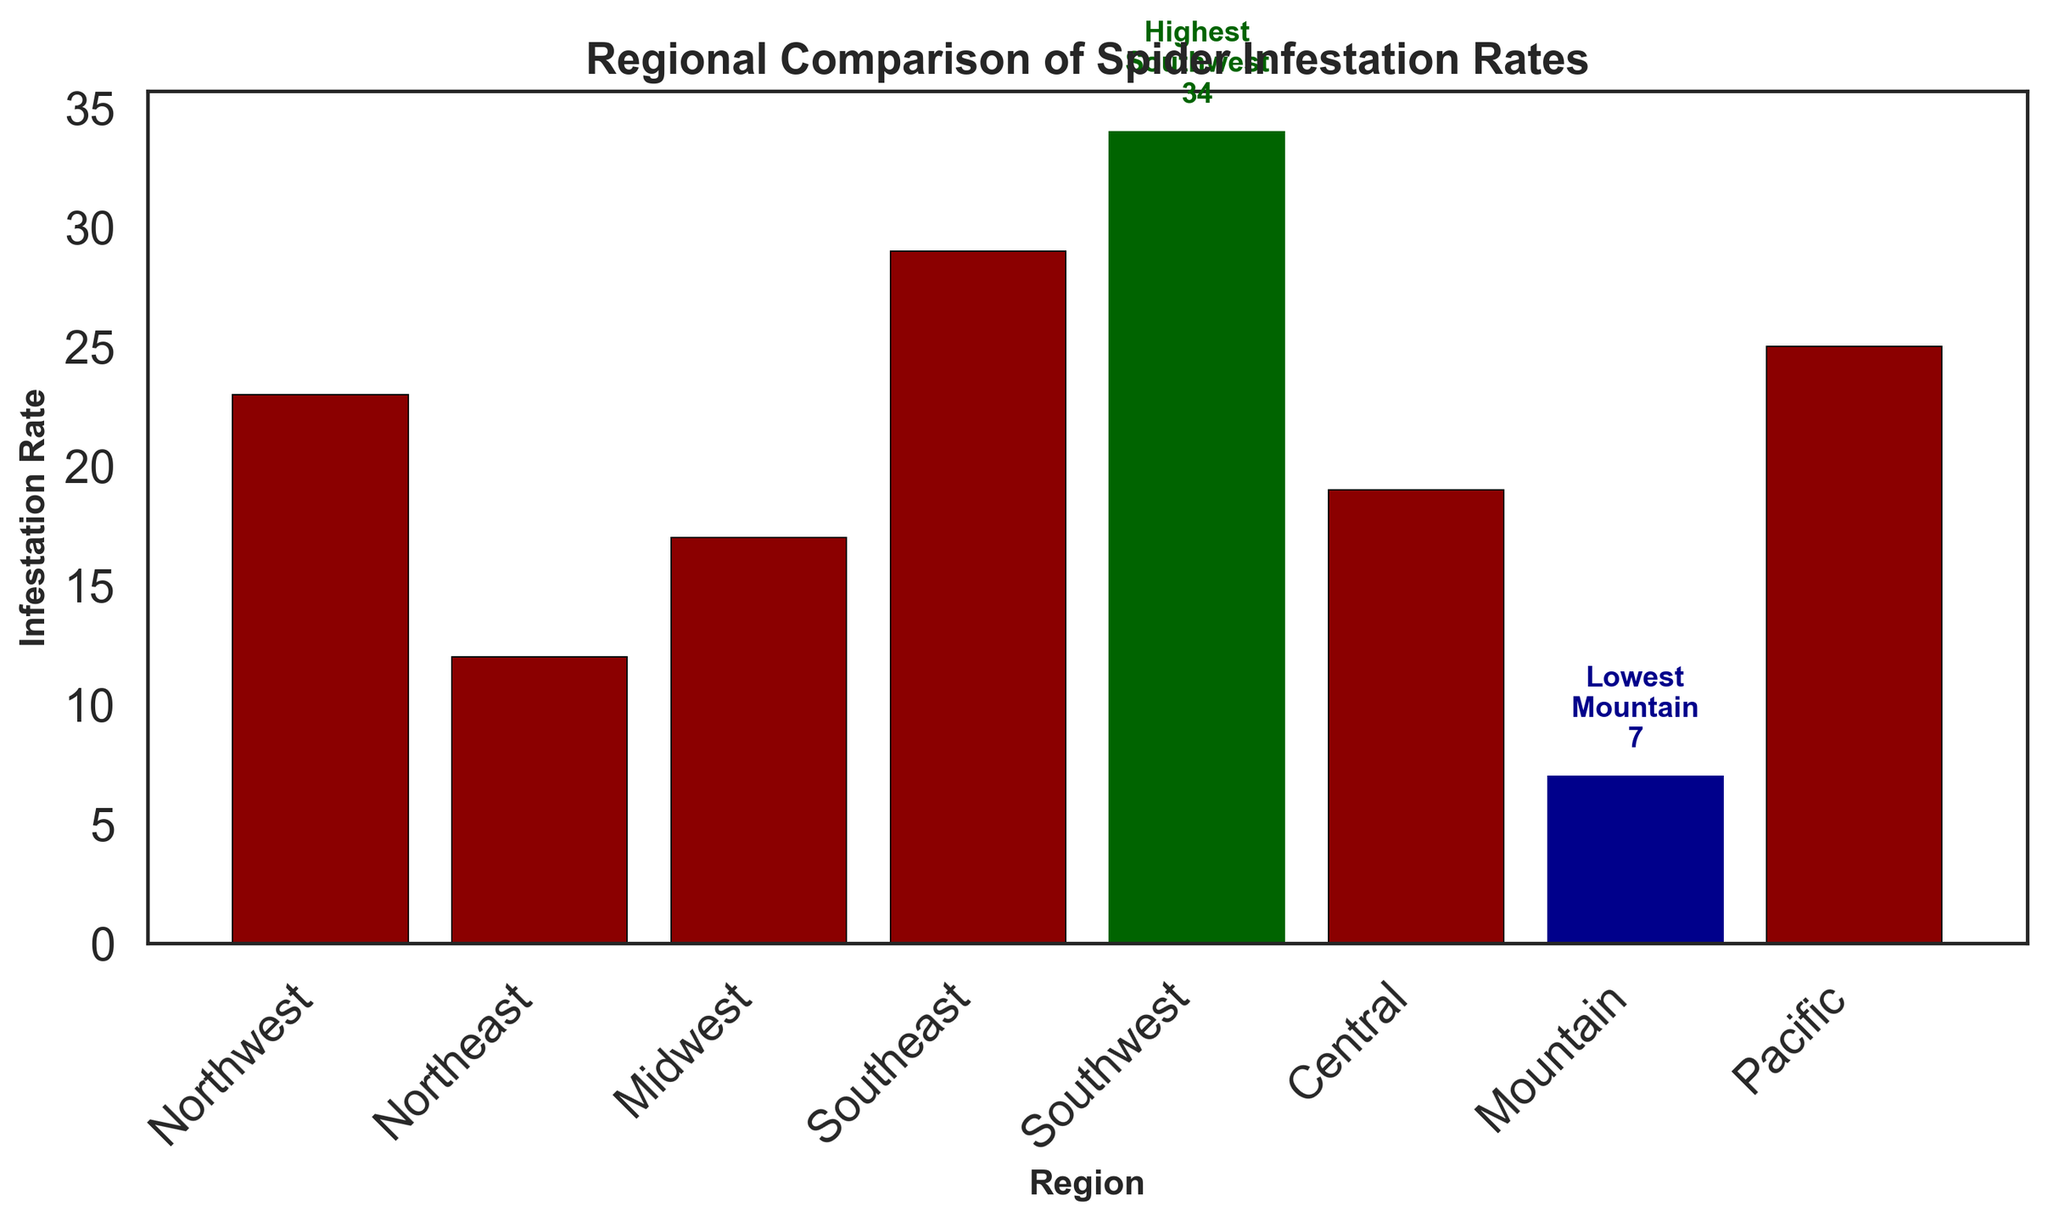Which region has the highest spider infestation rate? The region with the highest infestation rate is highlighted in dark green and annotated with "Highest." In this case, it is the Southwest region with a rate of 34.
Answer: Southwest Which region has the lowest spider infestation rate? The region with the lowest infestation rate is highlighted in dark blue and annotated with "Lowest." In this case, it is the Mountain region with a rate of 7.
Answer: Mountain What is the difference in infestation rates between the Southwest and the Southeast regions? The infestation rate in the Southwest is 34 and in the Southeast is 29. The difference is calculated as 34 - 29 = 5.
Answer: 5 What is the average spider infestation rate across all regions? Sum the infestation rates of all regions: 23 (Northwest) + 12 (Northeast) + 17 (Midwest) + 29 (Southeast) + 34 (Southwest) + 19 (Central) + 7 (Mountain) + 25 (Pacific) = 166. Then, divide by the number of regions (8): 166 / 8 = 20.75.
Answer: 20.75 Which region has a higher infestation rate, the Midwest or the Pacific? The infestation rate in the Midwest is 17 and in the Pacific is 25. Since 25 is greater than 17, the Pacific has a higher infestation rate.
Answer: Pacific What is the total infestation rate for the Northwest and Central regions combined? The infestation rates for the Northwest and Central regions are 23 and 19, respectively. Adding these together results in 23 + 19 = 42.
Answer: 42 Which region has an infestation rate closest to the median value of all regions? The infestation rates in descending order: 34 (Southwest), 29 (Southeast), 25 (Pacific), 23 (Northwest), 19 (Central), 17 (Midwest), 12 (Northeast), 7 (Mountain). The median is the average of the 4th and 5th values: (23 + 19) / 2 = 21. The Central region, with a rate of 19, is closest to the median.
Answer: Central How many regions have a spider infestation rate above the average? The average infestation rate is 20.75. The regions with rates above this are Northwest (23), Southeast (29), Southwest (34), and Pacific (25). This is a total of 4 regions.
Answer: 4 Which two regions have the smallest difference in their infestation rates? Calculate the difference between the infestation rates of each adjacent pair of regions: Northwest-Central (23-19=4), Midwest-Northeast (17-12=5), Southeast-Southwest (34-29=5), Mountain-Northeast (12-7=5). The smallest difference is between Northwest and Central, which is 4.
Answer: Northwest and Central What are the colors used to highlight the regions with the highest and lowest infestation rates on the bar chart? The highest infestation rate is highlighted in dark green and the lowest infestation rate is highlighted in dark blue as per the annotations and color coding.
Answer: Dark green (highest) and Dark blue (lowest) 